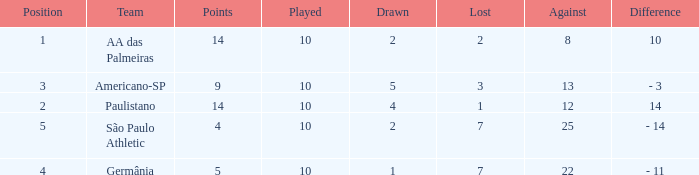What team has an against more than 8, lost of 7, and the position is 5? São Paulo Athletic. 